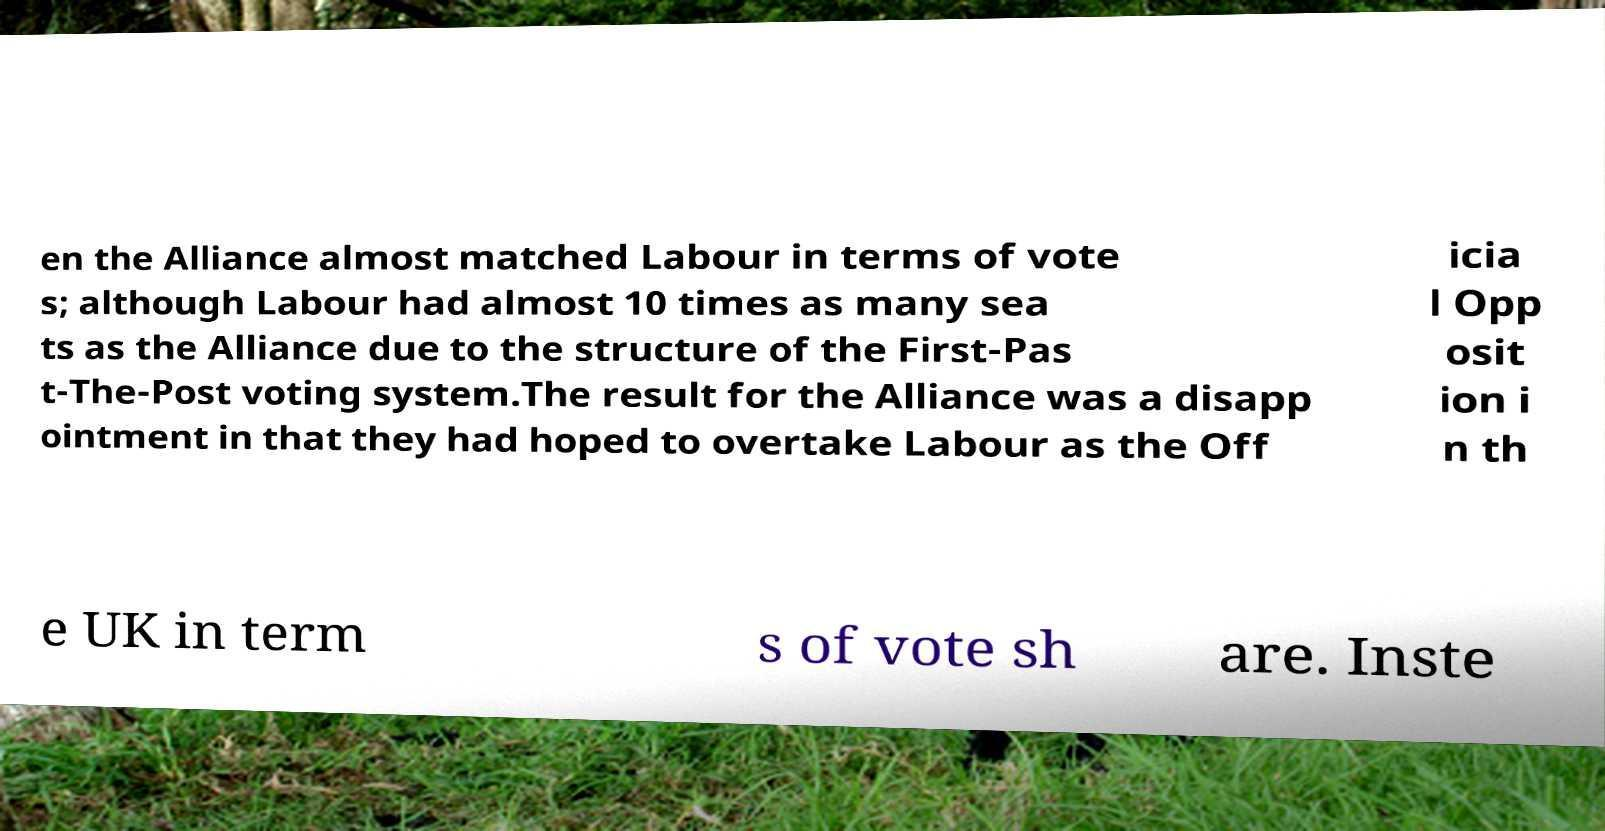I need the written content from this picture converted into text. Can you do that? en the Alliance almost matched Labour in terms of vote s; although Labour had almost 10 times as many sea ts as the Alliance due to the structure of the First-Pas t-The-Post voting system.The result for the Alliance was a disapp ointment in that they had hoped to overtake Labour as the Off icia l Opp osit ion i n th e UK in term s of vote sh are. Inste 